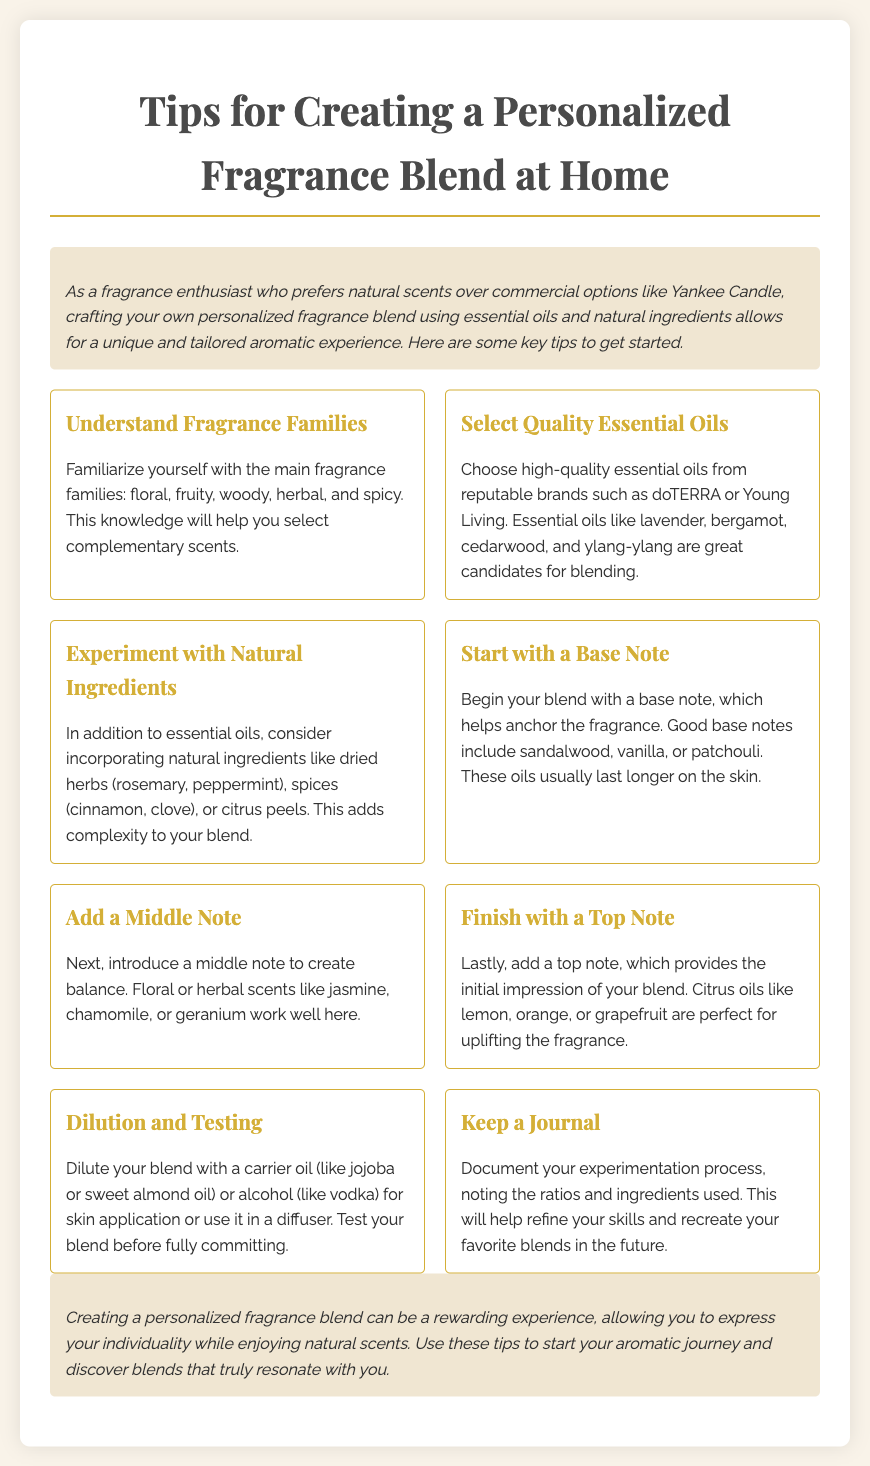What are the main fragrance families? The document lists the main fragrance families as floral, fruity, woody, herbal, and spicy.
Answer: floral, fruity, woody, herbal, spicy Which essential oils are recommended for blending? The document suggests high-quality essential oils like lavender, bergamot, cedarwood, and ylang-ylang for blending.
Answer: lavender, bergamot, cedarwood, ylang-ylang What is the purpose of a base note in a fragrance blend? The document states that a base note helps anchor the fragrance and usually lasts longer on the skin.
Answer: anchor the fragrance What should you document during the blending process? According to the document, you should document the ratios and ingredients used in your experiments.
Answer: ratios and ingredients What types of natural ingredients can be added? The document mentions incorporating dried herbs, spices, or citrus peels as natural ingredients.
Answer: dried herbs, spices, citrus peels How do you incorporate a top note in your blend? The document advises finishing your blend with a top note, suggesting citrus oils like lemon, orange, or grapefruit.
Answer: citrus oils like lemon, orange, or grapefruit What should be used for dilution when applying on skin? The document recommends diluting with a carrier oil like jojoba or sweet almond oil or alcohol like vodka.
Answer: carrier oil or alcohol What is one suggested middle note for balancing the fragrance? The document lists floral or herbal scents such as jasmine, chamomile, or geranium.
Answer: jasmine, chamomile, or geranium 